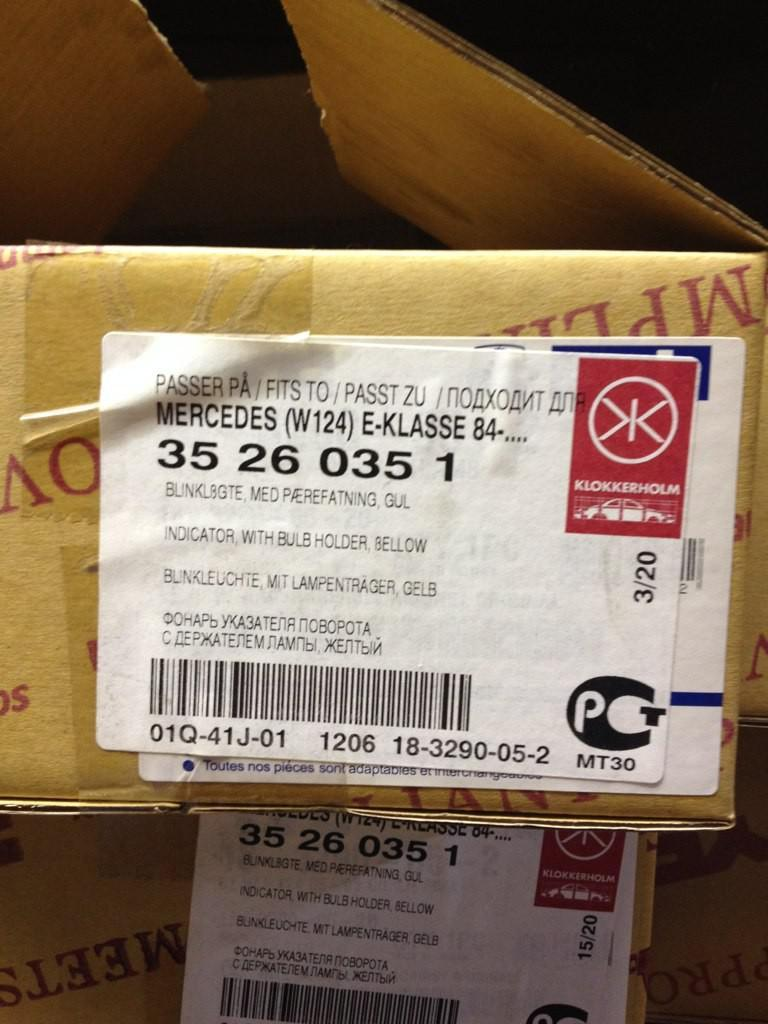<image>
Summarize the visual content of the image. A package with the number 35260351 on it has a red sticker on the label. 